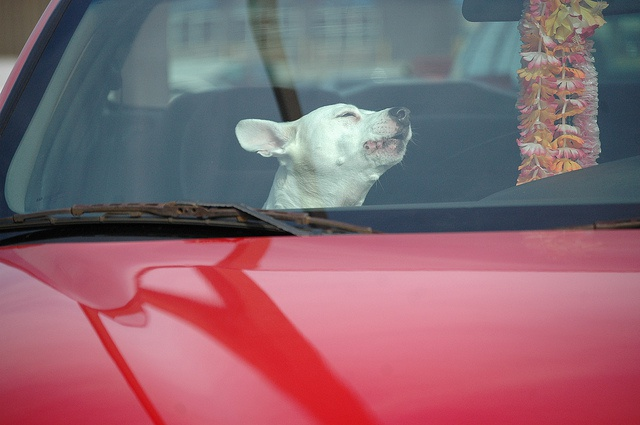Describe the objects in this image and their specific colors. I can see car in gray, brown, lightpink, and salmon tones and dog in gray, darkgray, beige, and lightblue tones in this image. 